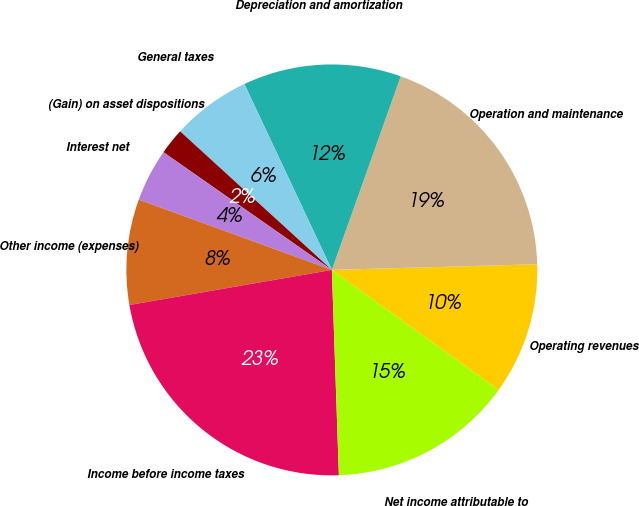Convert chart. <chart><loc_0><loc_0><loc_500><loc_500><pie_chart><fcel>Operating revenues<fcel>Operation and maintenance<fcel>Depreciation and amortization<fcel>General taxes<fcel>(Gain) on asset dispositions<fcel>Interest net<fcel>Other income (expenses)<fcel>Income before income taxes<fcel>Net income attributable to<nl><fcel>10.37%<fcel>19.12%<fcel>12.44%<fcel>6.22%<fcel>2.07%<fcel>4.15%<fcel>8.29%<fcel>22.81%<fcel>14.52%<nl></chart> 